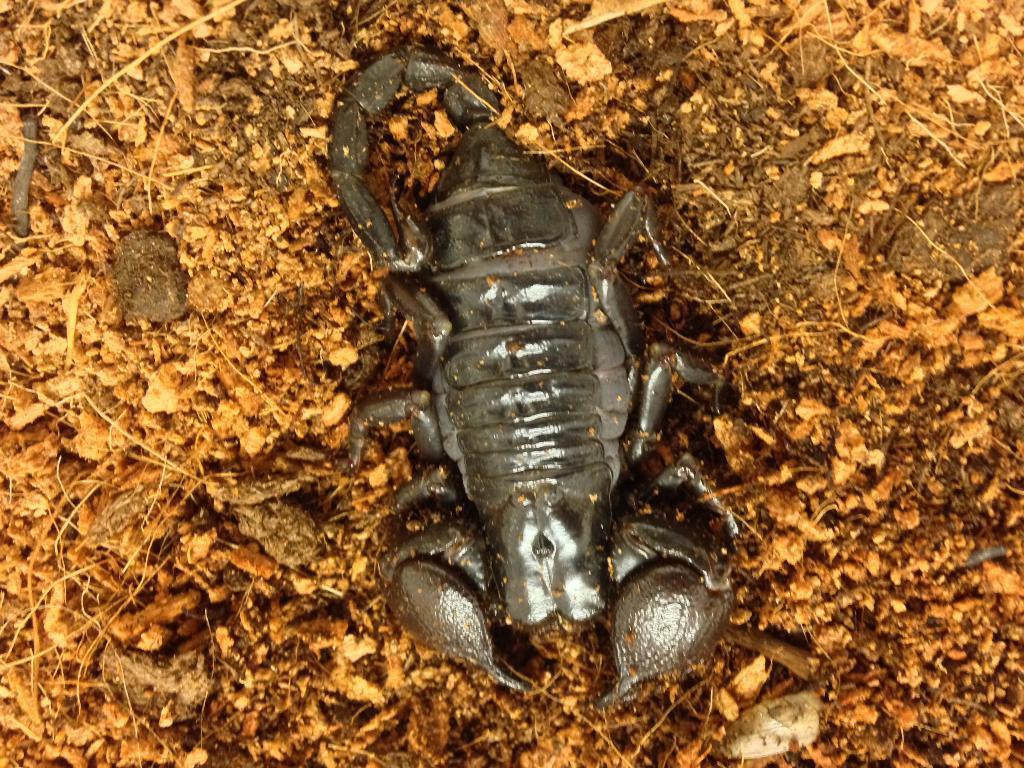Could you give a brief overview of what you see in this image? In the image there is a scorpion on the ground. 